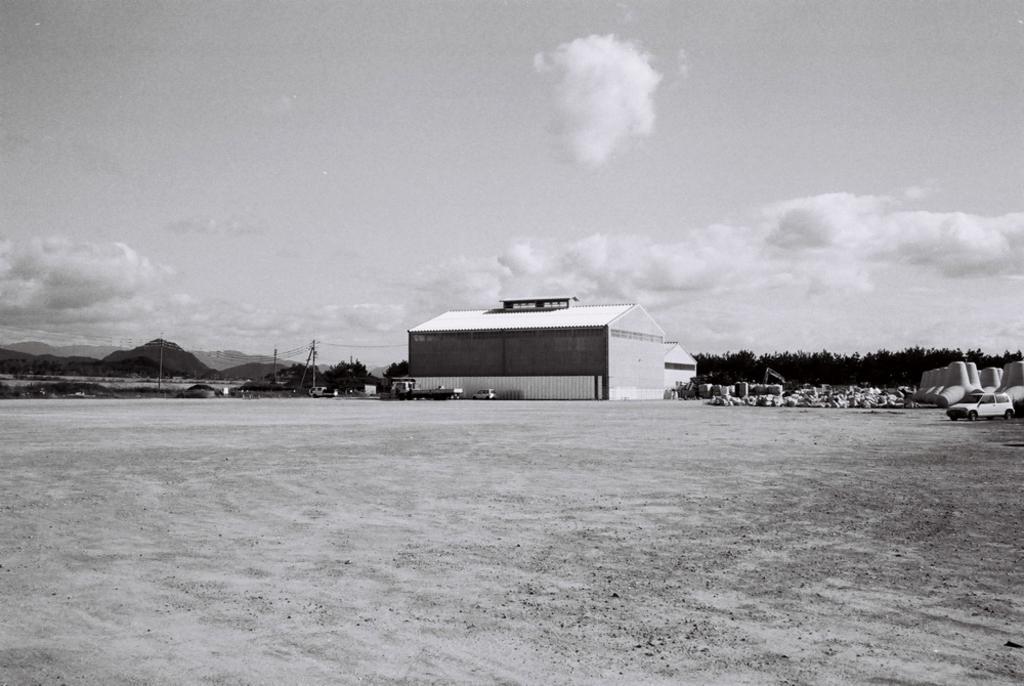How would you summarize this image in a sentence or two? In this image we can see vehicles on the surface and there is a shed. Behind the shed there are mountains and trees with a clear sky. 